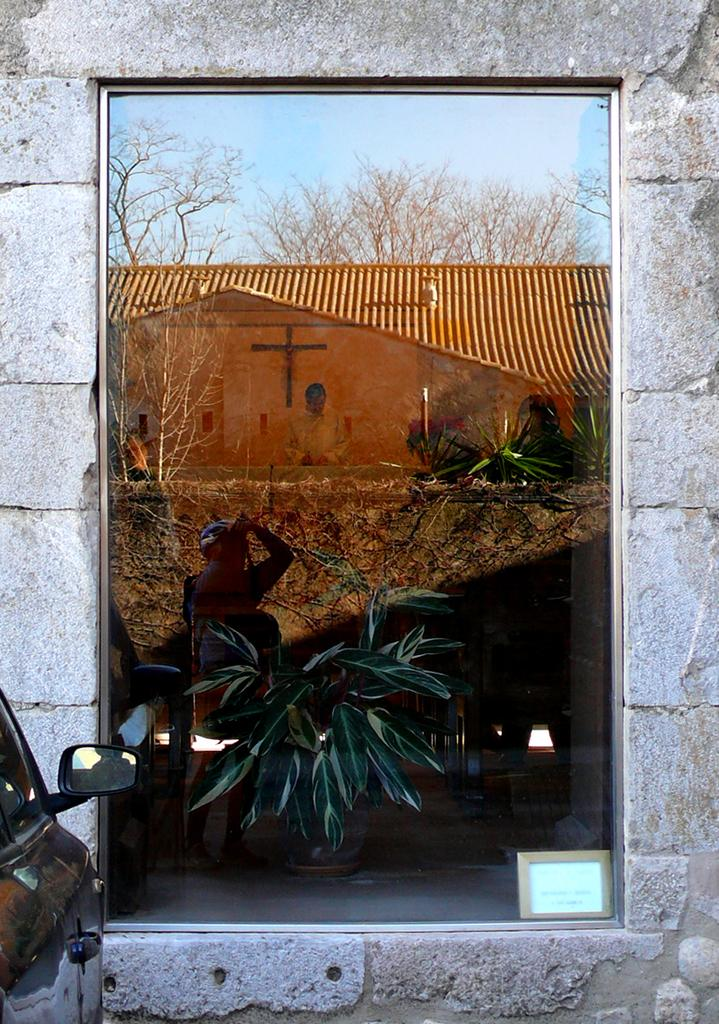What is the main subject of the image? The image depicts a building. What can be seen in the mirror in the image? The reflection of a person, the building, trees, and the sky are visible in the mirror. Where is the vehicle located in the image? The vehicle is on the left side of the image. How many branches can be seen in the image? There is no mention of branches in the image; it primarily features a building, a mirror, and a vehicle. What type of class is being held in the image? There is no indication of a class or any educational activity in the image. 